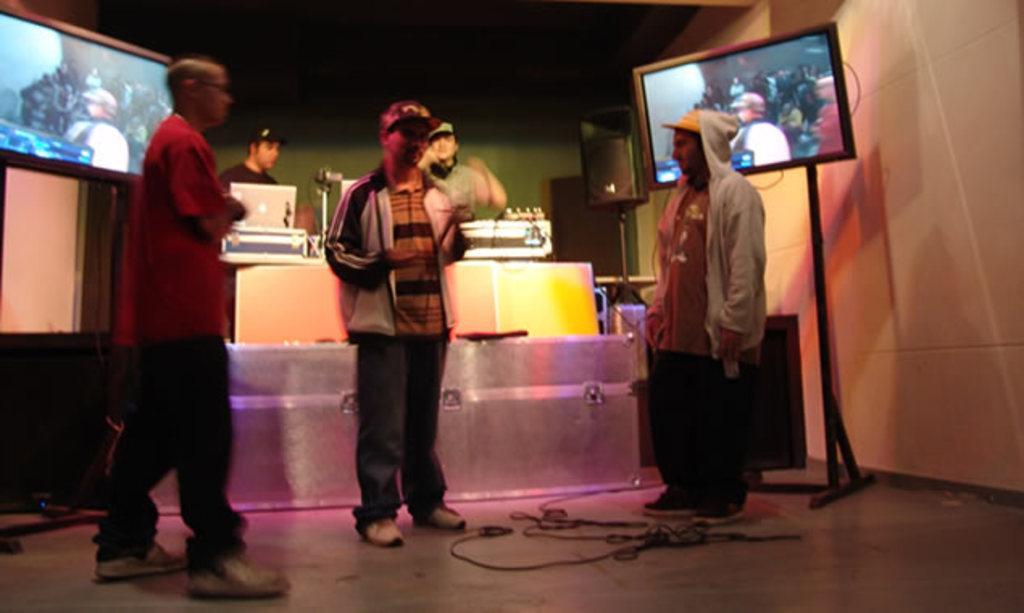In one or two sentences, can you explain what this image depicts? In this image we can see a few people, there are two screens, also we can see the speakers, cables and a table, on the table, there is a laptop and some other objects, in the background, we can see the wall. 